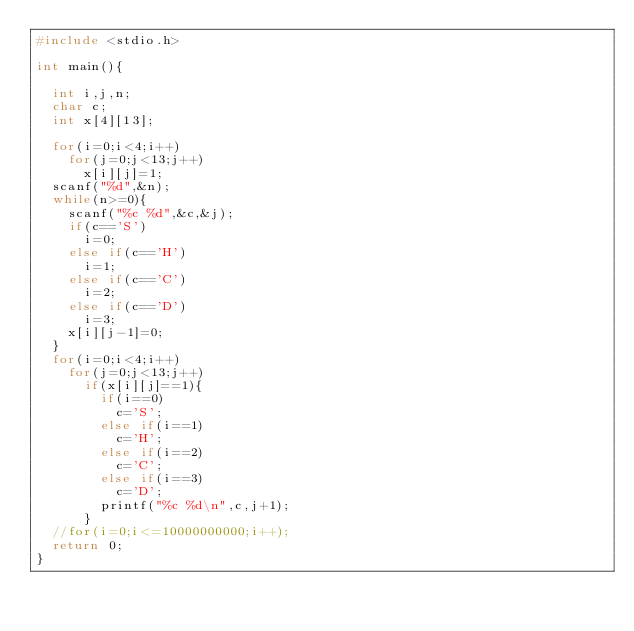<code> <loc_0><loc_0><loc_500><loc_500><_C_>#include <stdio.h>

int main(){

	int i,j,n;
	char c;
	int x[4][13];

	for(i=0;i<4;i++)
		for(j=0;j<13;j++)
			x[i][j]=1;
	scanf("%d",&n);
	while(n>=0){
		scanf("%c %d",&c,&j);
		if(c=='S')
			i=0;
		else if(c=='H')
			i=1;
		else if(c=='C')
			i=2;
		else if(c=='D')
			i=3;
		x[i][j-1]=0;
	}
	for(i=0;i<4;i++)
		for(j=0;j<13;j++)
			if(x[i][j]==1){
				if(i==0)
					c='S';
				else if(i==1)
					c='H';
				else if(i==2)
					c='C';
				else if(i==3)
					c='D';
				printf("%c %d\n",c,j+1);
			}
	//for(i=0;i<=10000000000;i++);
	return 0;
}</code> 